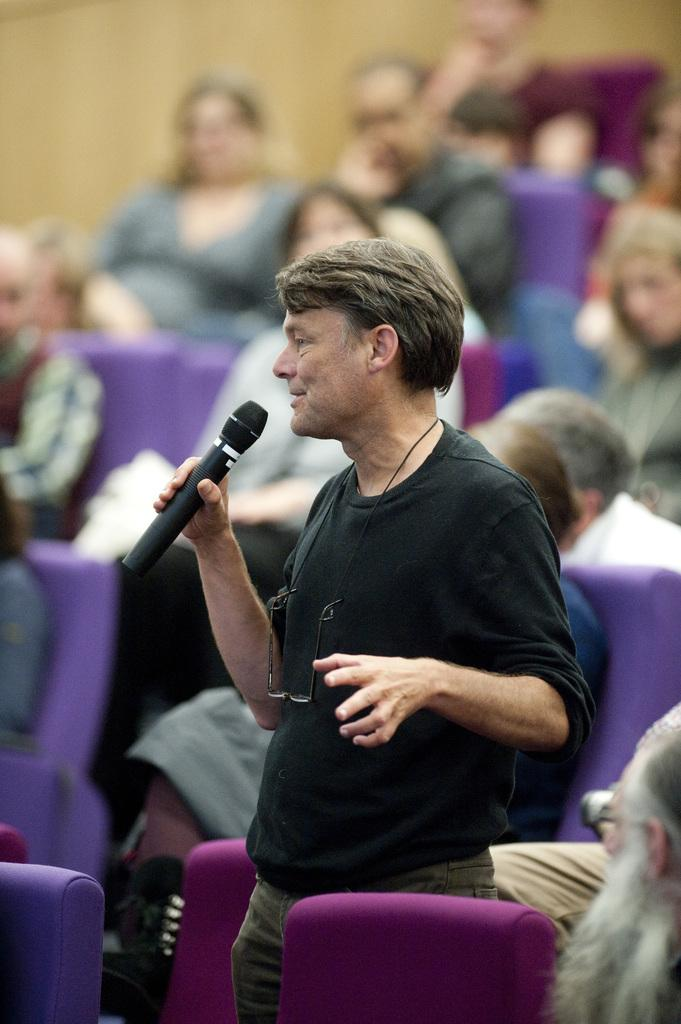What is the man in the image holding? The man is holding a mic in the image. What is the man doing with the mic? The man is talking while holding the mic. What can be seen in the background of the image? There is a group of people sitting on chairs in the background of the image. How would you describe the quality of the image? The image is blurry. What type of coal is being used to create noise in the image? There is no coal or noise present in the image; it features a man holding a mic and talking to a group of people sitting on chairs. 